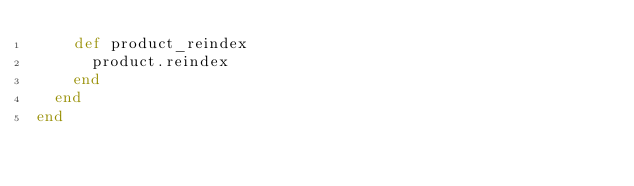Convert code to text. <code><loc_0><loc_0><loc_500><loc_500><_Ruby_>    def product_reindex
      product.reindex
    end
  end
end
</code> 